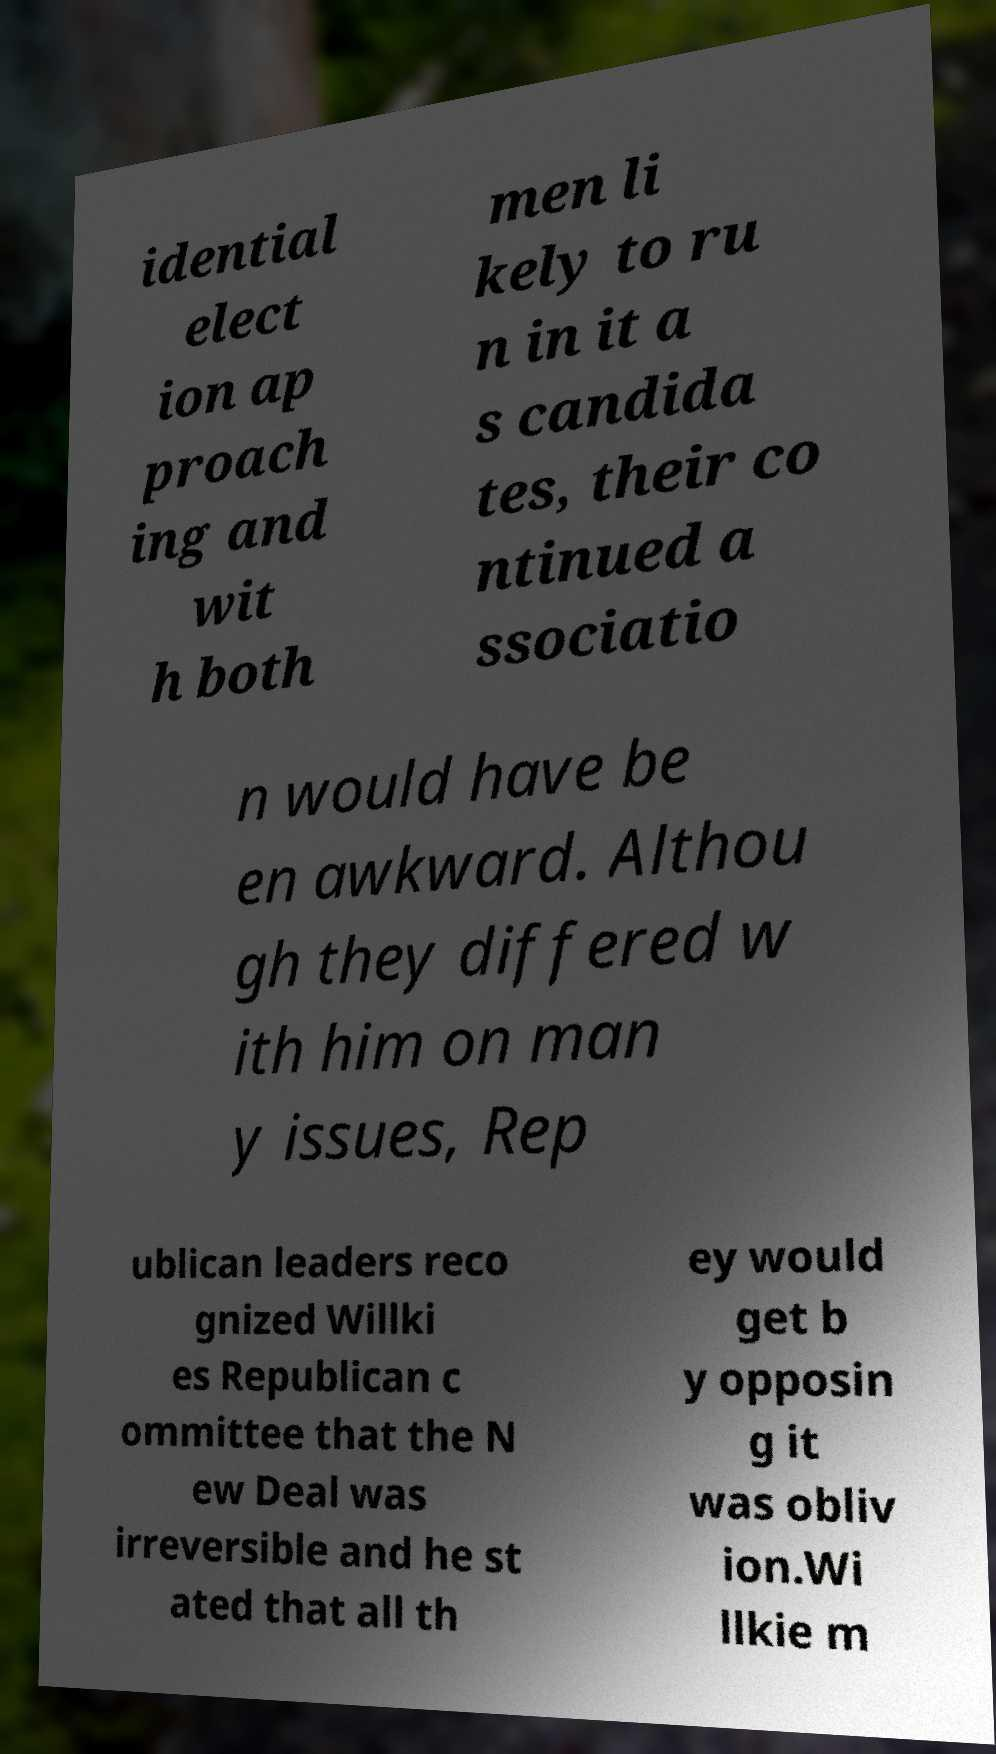I need the written content from this picture converted into text. Can you do that? idential elect ion ap proach ing and wit h both men li kely to ru n in it a s candida tes, their co ntinued a ssociatio n would have be en awkward. Althou gh they differed w ith him on man y issues, Rep ublican leaders reco gnized Willki es Republican c ommittee that the N ew Deal was irreversible and he st ated that all th ey would get b y opposin g it was obliv ion.Wi llkie m 